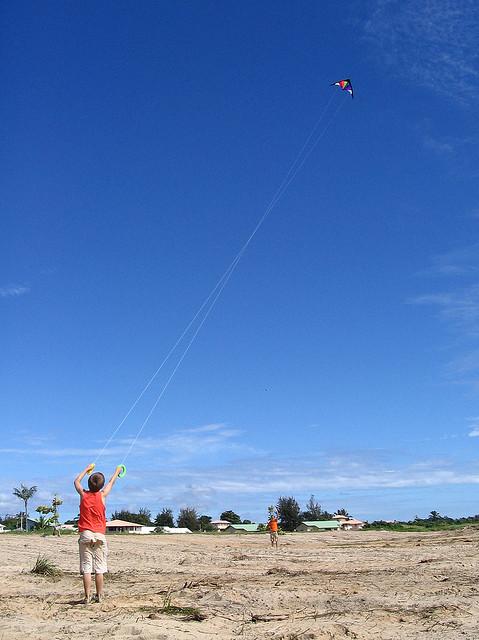What is he doing?
Answer briefly. Flying kite. What color is the string holder in the boy's left hand?
Write a very short answer. White. Is the kite high off the ground?
Short answer required. Yes. Is this person using both arms to control the kite?
Concise answer only. Yes. 